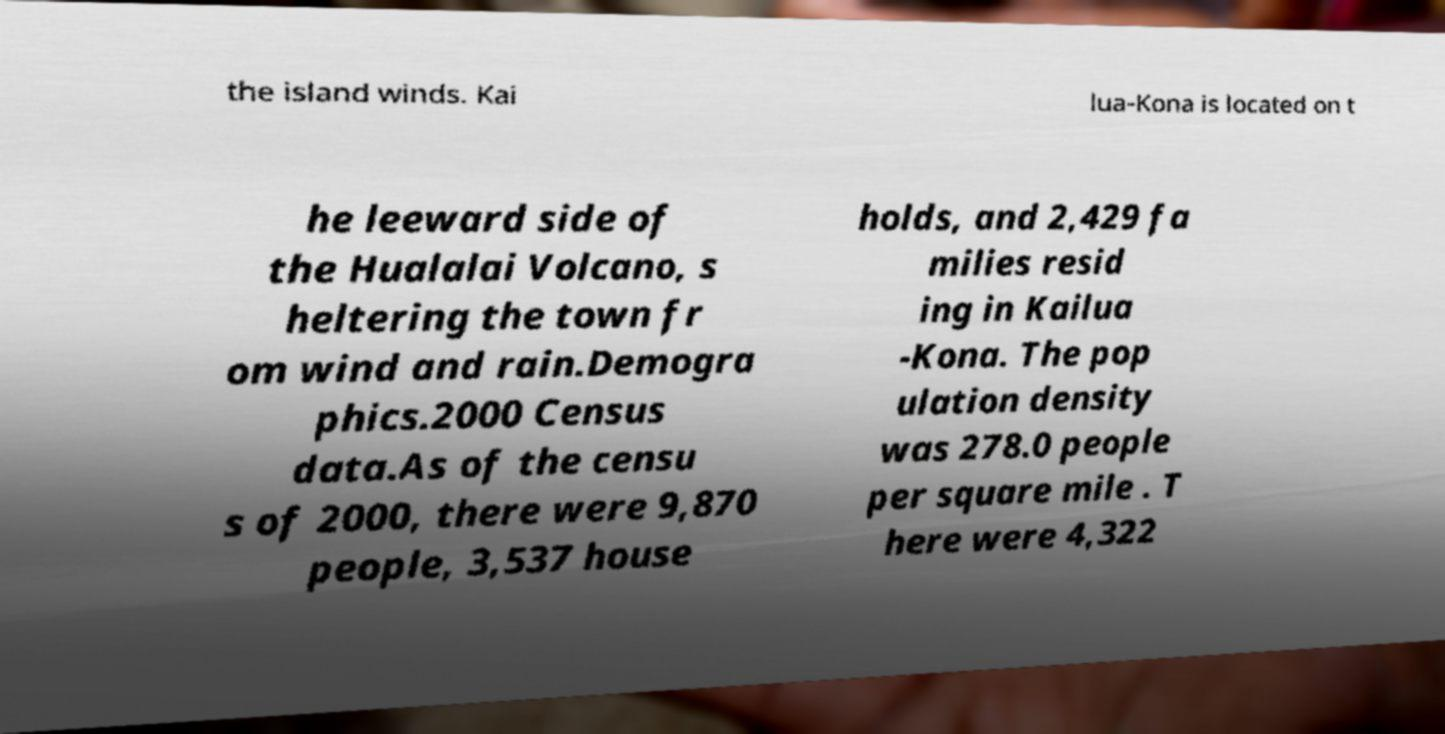Can you read and provide the text displayed in the image?This photo seems to have some interesting text. Can you extract and type it out for me? the island winds. Kai lua-Kona is located on t he leeward side of the Hualalai Volcano, s heltering the town fr om wind and rain.Demogra phics.2000 Census data.As of the censu s of 2000, there were 9,870 people, 3,537 house holds, and 2,429 fa milies resid ing in Kailua -Kona. The pop ulation density was 278.0 people per square mile . T here were 4,322 